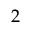Convert formula to latex. <formula><loc_0><loc_0><loc_500><loc_500>2</formula> 